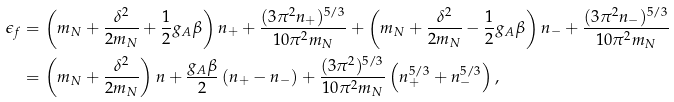Convert formula to latex. <formula><loc_0><loc_0><loc_500><loc_500>\epsilon _ { f } & = \left ( m _ { N } + \frac { \delta ^ { 2 } } { 2 m _ { N } } + \frac { 1 } { 2 } g _ { A } \beta \right ) n _ { + } + \frac { ( 3 \pi ^ { 2 } n _ { + } ) ^ { 5 / 3 } } { 1 0 \pi ^ { 2 } m _ { N } } + \left ( m _ { N } + \frac { \delta ^ { 2 } } { 2 m _ { N } } - \frac { 1 } { 2 } g _ { A } \beta \right ) n _ { - } + \frac { ( 3 \pi ^ { 2 } n _ { - } ) ^ { 5 / 3 } } { 1 0 \pi ^ { 2 } m _ { N } } \\ & = \left ( m _ { N } + \frac { \delta ^ { 2 } } { 2 m _ { N } } \right ) n + \frac { g _ { A } \beta } { 2 } \left ( n _ { + } - n _ { - } \right ) + \frac { ( 3 \pi ^ { 2 } ) ^ { 5 / 3 } } { 1 0 \pi ^ { 2 } m _ { N } } \left ( n _ { + } ^ { 5 / 3 } + n _ { - } ^ { 5 / 3 } \right ) ,</formula> 